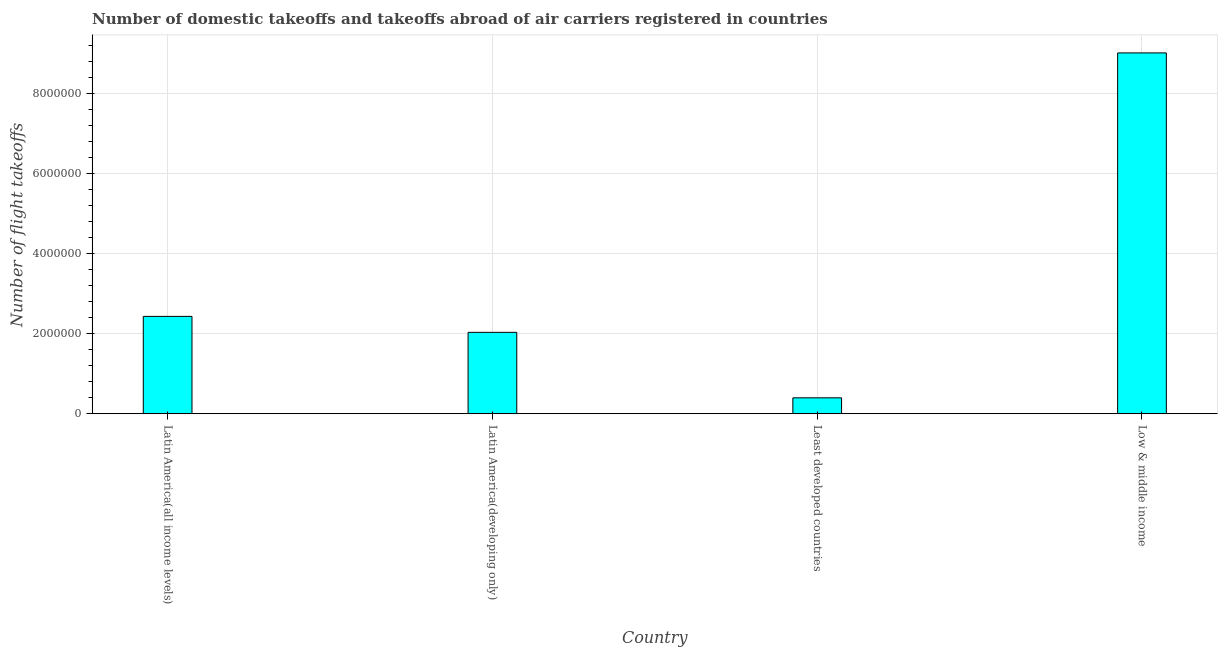Does the graph contain grids?
Offer a very short reply. Yes. What is the title of the graph?
Make the answer very short. Number of domestic takeoffs and takeoffs abroad of air carriers registered in countries. What is the label or title of the Y-axis?
Ensure brevity in your answer.  Number of flight takeoffs. What is the number of flight takeoffs in Least developed countries?
Give a very brief answer. 3.97e+05. Across all countries, what is the maximum number of flight takeoffs?
Offer a terse response. 9.01e+06. Across all countries, what is the minimum number of flight takeoffs?
Your answer should be compact. 3.97e+05. In which country was the number of flight takeoffs minimum?
Provide a short and direct response. Least developed countries. What is the sum of the number of flight takeoffs?
Offer a terse response. 1.39e+07. What is the difference between the number of flight takeoffs in Latin America(developing only) and Least developed countries?
Your response must be concise. 1.64e+06. What is the average number of flight takeoffs per country?
Ensure brevity in your answer.  3.47e+06. What is the median number of flight takeoffs?
Offer a very short reply. 2.23e+06. In how many countries, is the number of flight takeoffs greater than 7600000 ?
Give a very brief answer. 1. What is the ratio of the number of flight takeoffs in Latin America(all income levels) to that in Low & middle income?
Ensure brevity in your answer.  0.27. Is the number of flight takeoffs in Least developed countries less than that in Low & middle income?
Provide a short and direct response. Yes. What is the difference between the highest and the second highest number of flight takeoffs?
Your response must be concise. 6.58e+06. What is the difference between the highest and the lowest number of flight takeoffs?
Your response must be concise. 8.61e+06. How many bars are there?
Make the answer very short. 4. Are all the bars in the graph horizontal?
Keep it short and to the point. No. How many countries are there in the graph?
Provide a succinct answer. 4. What is the Number of flight takeoffs of Latin America(all income levels)?
Your answer should be compact. 2.43e+06. What is the Number of flight takeoffs of Latin America(developing only)?
Make the answer very short. 2.03e+06. What is the Number of flight takeoffs of Least developed countries?
Ensure brevity in your answer.  3.97e+05. What is the Number of flight takeoffs of Low & middle income?
Make the answer very short. 9.01e+06. What is the difference between the Number of flight takeoffs in Latin America(all income levels) and Latin America(developing only)?
Keep it short and to the point. 3.99e+05. What is the difference between the Number of flight takeoffs in Latin America(all income levels) and Least developed countries?
Ensure brevity in your answer.  2.03e+06. What is the difference between the Number of flight takeoffs in Latin America(all income levels) and Low & middle income?
Make the answer very short. -6.58e+06. What is the difference between the Number of flight takeoffs in Latin America(developing only) and Least developed countries?
Offer a very short reply. 1.64e+06. What is the difference between the Number of flight takeoffs in Latin America(developing only) and Low & middle income?
Your response must be concise. -6.98e+06. What is the difference between the Number of flight takeoffs in Least developed countries and Low & middle income?
Your response must be concise. -8.61e+06. What is the ratio of the Number of flight takeoffs in Latin America(all income levels) to that in Latin America(developing only)?
Your answer should be very brief. 1.2. What is the ratio of the Number of flight takeoffs in Latin America(all income levels) to that in Least developed countries?
Keep it short and to the point. 6.12. What is the ratio of the Number of flight takeoffs in Latin America(all income levels) to that in Low & middle income?
Offer a terse response. 0.27. What is the ratio of the Number of flight takeoffs in Latin America(developing only) to that in Least developed countries?
Offer a very short reply. 5.11. What is the ratio of the Number of flight takeoffs in Latin America(developing only) to that in Low & middle income?
Make the answer very short. 0.23. What is the ratio of the Number of flight takeoffs in Least developed countries to that in Low & middle income?
Offer a very short reply. 0.04. 